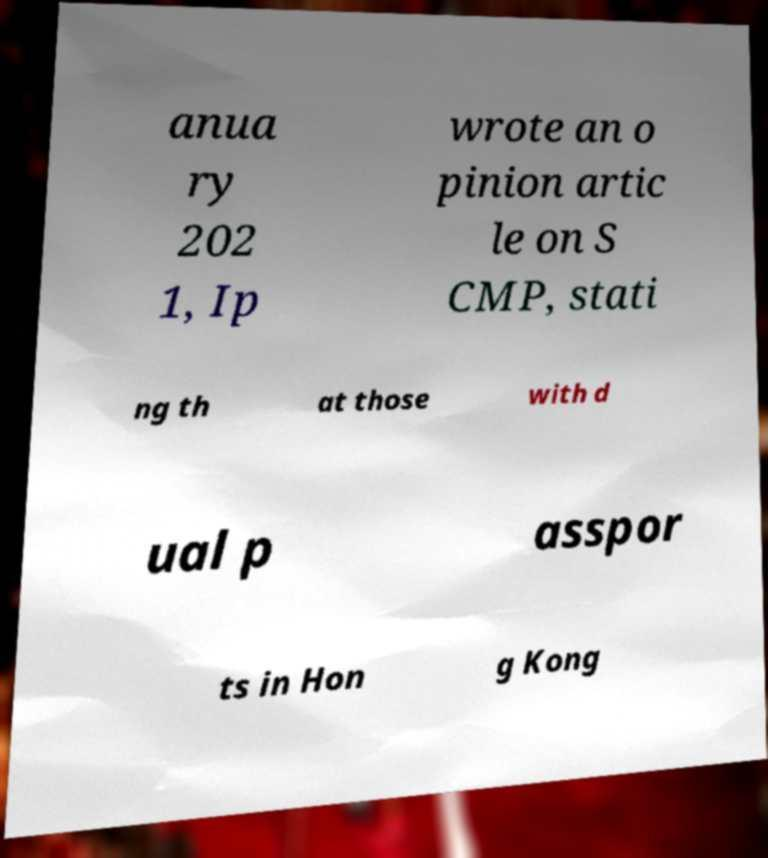Can you read and provide the text displayed in the image?This photo seems to have some interesting text. Can you extract and type it out for me? anua ry 202 1, Ip wrote an o pinion artic le on S CMP, stati ng th at those with d ual p asspor ts in Hon g Kong 